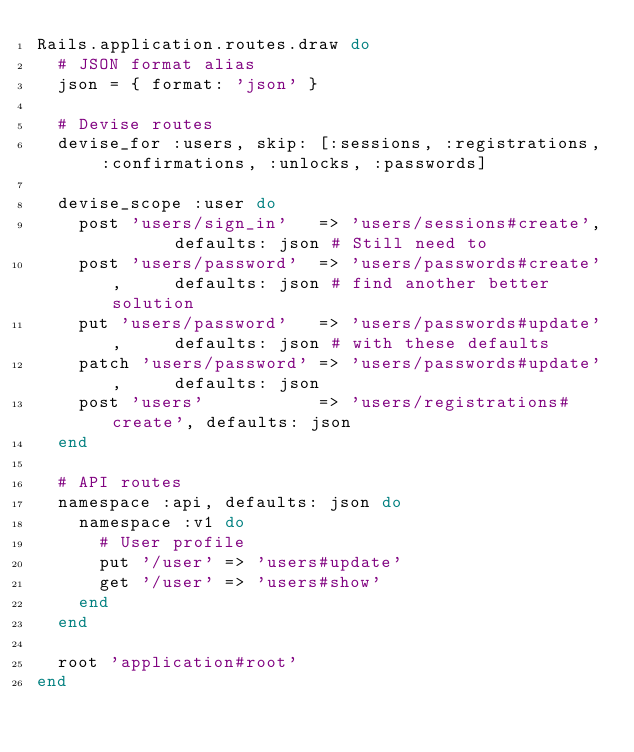Convert code to text. <code><loc_0><loc_0><loc_500><loc_500><_Ruby_>Rails.application.routes.draw do
  # JSON format alias
  json = { format: 'json' }

  # Devise routes
  devise_for :users, skip: [:sessions, :registrations, :confirmations, :unlocks, :passwords]

  devise_scope :user do
    post 'users/sign_in'   => 'users/sessions#create',      defaults: json # Still need to
    post 'users/password'  => 'users/passwords#create',     defaults: json # find another better solution
    put 'users/password'   => 'users/passwords#update',     defaults: json # with these defaults
    patch 'users/password' => 'users/passwords#update',     defaults: json
    post 'users'           => 'users/registrations#create', defaults: json
  end

  # API routes
  namespace :api, defaults: json do
    namespace :v1 do
      # User profile
      put '/user' => 'users#update'
      get '/user' => 'users#show'
    end
  end

  root 'application#root'
end
</code> 